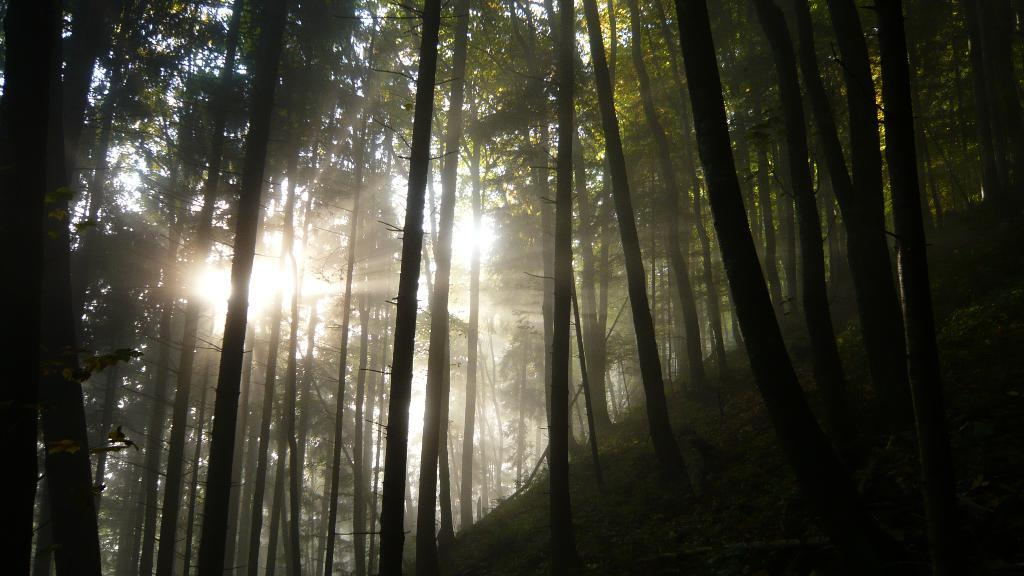What type of vegetation is in the foreground of the image? There are trees in the foreground of the image. What celestial body is visible in the background of the image? The sun is visible in the background of the image. What can be observed coming from the sun in the image? The sun's rays are visible in the background of the image. Where is the toad located in the image? There is no toad present in the image. What type of attraction can be seen in the image? There is no attraction present in the image; it features trees and the sun. 